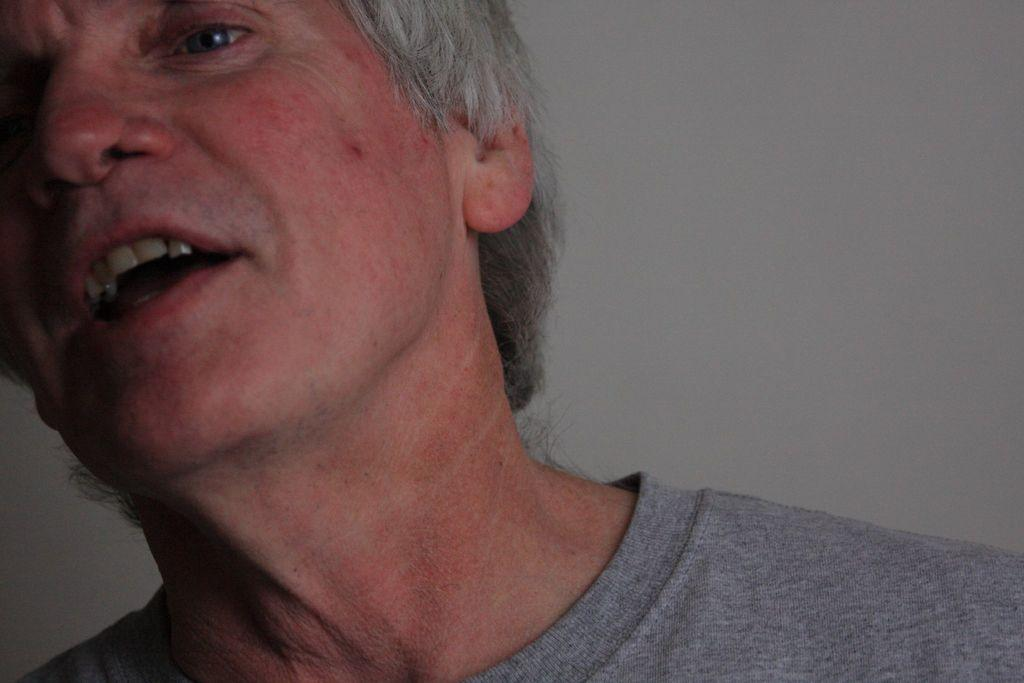What is present in the image? There is a person in the image. Can you describe the person's appearance? The person has gray hair. Is there any part of the person's head that is not fully visible in the image? Yes, some part of the person's head has been truncated. What type of pail is the person holding in the image? There is no pail present in the image. Can you describe the person's tail in the image? There is no tail present on the person in the image. 